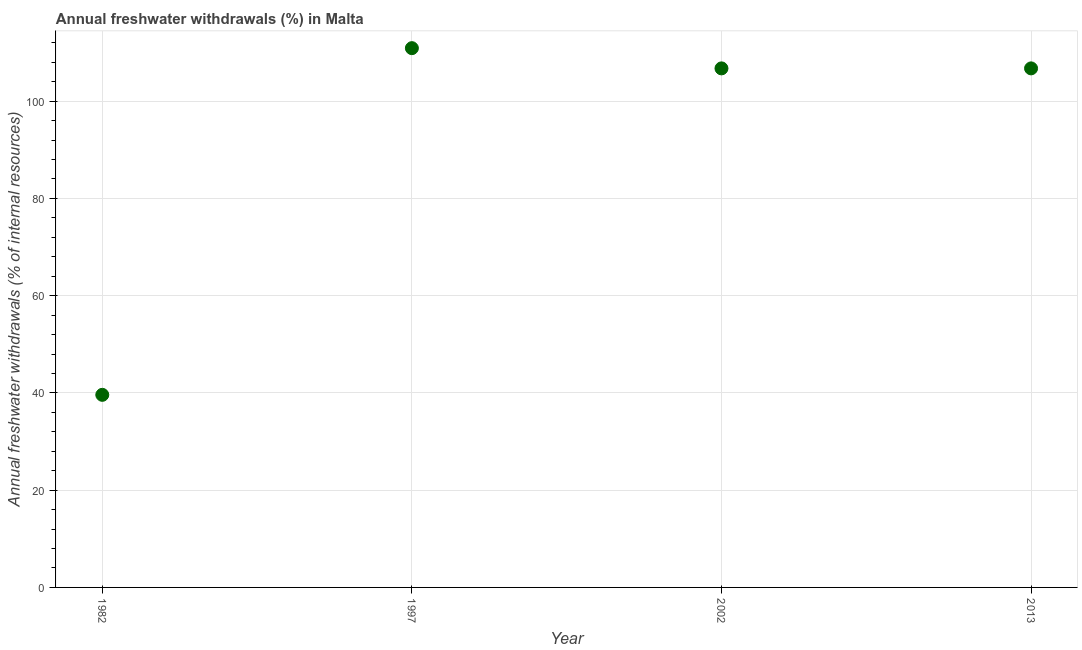What is the annual freshwater withdrawals in 1982?
Your answer should be very brief. 39.6. Across all years, what is the maximum annual freshwater withdrawals?
Provide a short and direct response. 110.89. Across all years, what is the minimum annual freshwater withdrawals?
Provide a succinct answer. 39.6. In which year was the annual freshwater withdrawals minimum?
Provide a short and direct response. 1982. What is the sum of the annual freshwater withdrawals?
Offer a very short reply. 363.96. What is the difference between the annual freshwater withdrawals in 2002 and 2013?
Ensure brevity in your answer.  0. What is the average annual freshwater withdrawals per year?
Keep it short and to the point. 90.99. What is the median annual freshwater withdrawals?
Your answer should be compact. 106.73. In how many years, is the annual freshwater withdrawals greater than 12 %?
Give a very brief answer. 4. What is the ratio of the annual freshwater withdrawals in 1997 to that in 2002?
Ensure brevity in your answer.  1.04. Is the annual freshwater withdrawals in 1997 less than that in 2013?
Offer a terse response. No. Is the difference between the annual freshwater withdrawals in 1982 and 1997 greater than the difference between any two years?
Offer a terse response. Yes. What is the difference between the highest and the second highest annual freshwater withdrawals?
Ensure brevity in your answer.  4.16. What is the difference between the highest and the lowest annual freshwater withdrawals?
Offer a terse response. 71.29. Does the annual freshwater withdrawals monotonically increase over the years?
Your answer should be very brief. No. How many dotlines are there?
Give a very brief answer. 1. How many years are there in the graph?
Ensure brevity in your answer.  4. What is the difference between two consecutive major ticks on the Y-axis?
Make the answer very short. 20. Does the graph contain any zero values?
Keep it short and to the point. No. What is the title of the graph?
Your response must be concise. Annual freshwater withdrawals (%) in Malta. What is the label or title of the Y-axis?
Your response must be concise. Annual freshwater withdrawals (% of internal resources). What is the Annual freshwater withdrawals (% of internal resources) in 1982?
Ensure brevity in your answer.  39.6. What is the Annual freshwater withdrawals (% of internal resources) in 1997?
Give a very brief answer. 110.89. What is the Annual freshwater withdrawals (% of internal resources) in 2002?
Your answer should be compact. 106.73. What is the Annual freshwater withdrawals (% of internal resources) in 2013?
Give a very brief answer. 106.73. What is the difference between the Annual freshwater withdrawals (% of internal resources) in 1982 and 1997?
Provide a short and direct response. -71.29. What is the difference between the Annual freshwater withdrawals (% of internal resources) in 1982 and 2002?
Make the answer very short. -67.13. What is the difference between the Annual freshwater withdrawals (% of internal resources) in 1982 and 2013?
Offer a very short reply. -67.13. What is the difference between the Annual freshwater withdrawals (% of internal resources) in 1997 and 2002?
Provide a short and direct response. 4.16. What is the difference between the Annual freshwater withdrawals (% of internal resources) in 1997 and 2013?
Ensure brevity in your answer.  4.16. What is the difference between the Annual freshwater withdrawals (% of internal resources) in 2002 and 2013?
Provide a short and direct response. 0. What is the ratio of the Annual freshwater withdrawals (% of internal resources) in 1982 to that in 1997?
Your response must be concise. 0.36. What is the ratio of the Annual freshwater withdrawals (% of internal resources) in 1982 to that in 2002?
Offer a terse response. 0.37. What is the ratio of the Annual freshwater withdrawals (% of internal resources) in 1982 to that in 2013?
Keep it short and to the point. 0.37. What is the ratio of the Annual freshwater withdrawals (% of internal resources) in 1997 to that in 2002?
Offer a terse response. 1.04. What is the ratio of the Annual freshwater withdrawals (% of internal resources) in 1997 to that in 2013?
Your answer should be very brief. 1.04. What is the ratio of the Annual freshwater withdrawals (% of internal resources) in 2002 to that in 2013?
Provide a short and direct response. 1. 